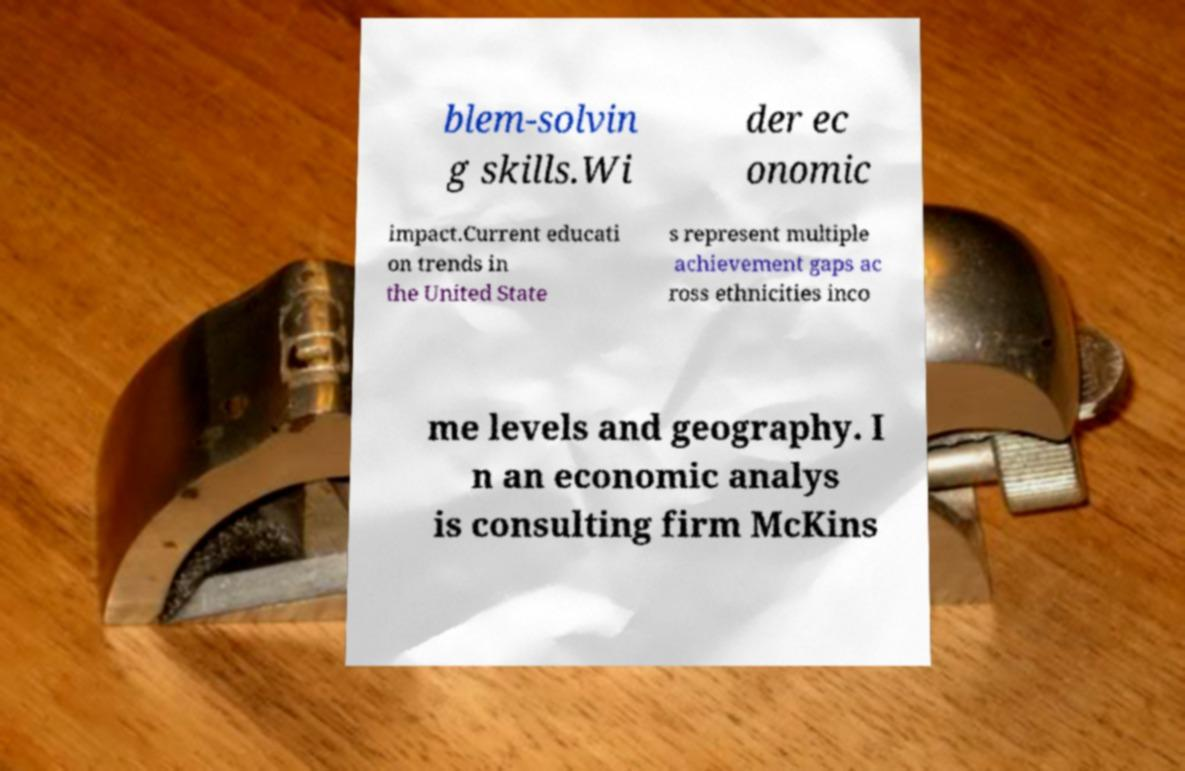I need the written content from this picture converted into text. Can you do that? blem-solvin g skills.Wi der ec onomic impact.Current educati on trends in the United State s represent multiple achievement gaps ac ross ethnicities inco me levels and geography. I n an economic analys is consulting firm McKins 